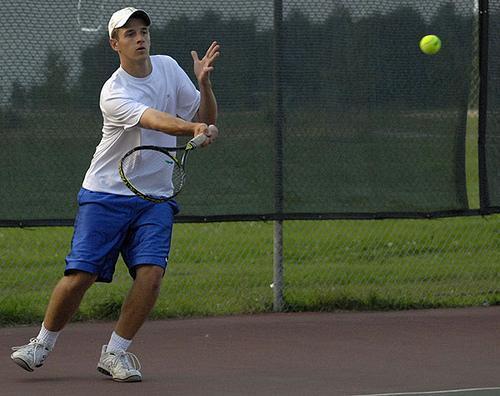How many persons are wearing hats?
Give a very brief answer. 1. How many people are visible?
Give a very brief answer. 1. 